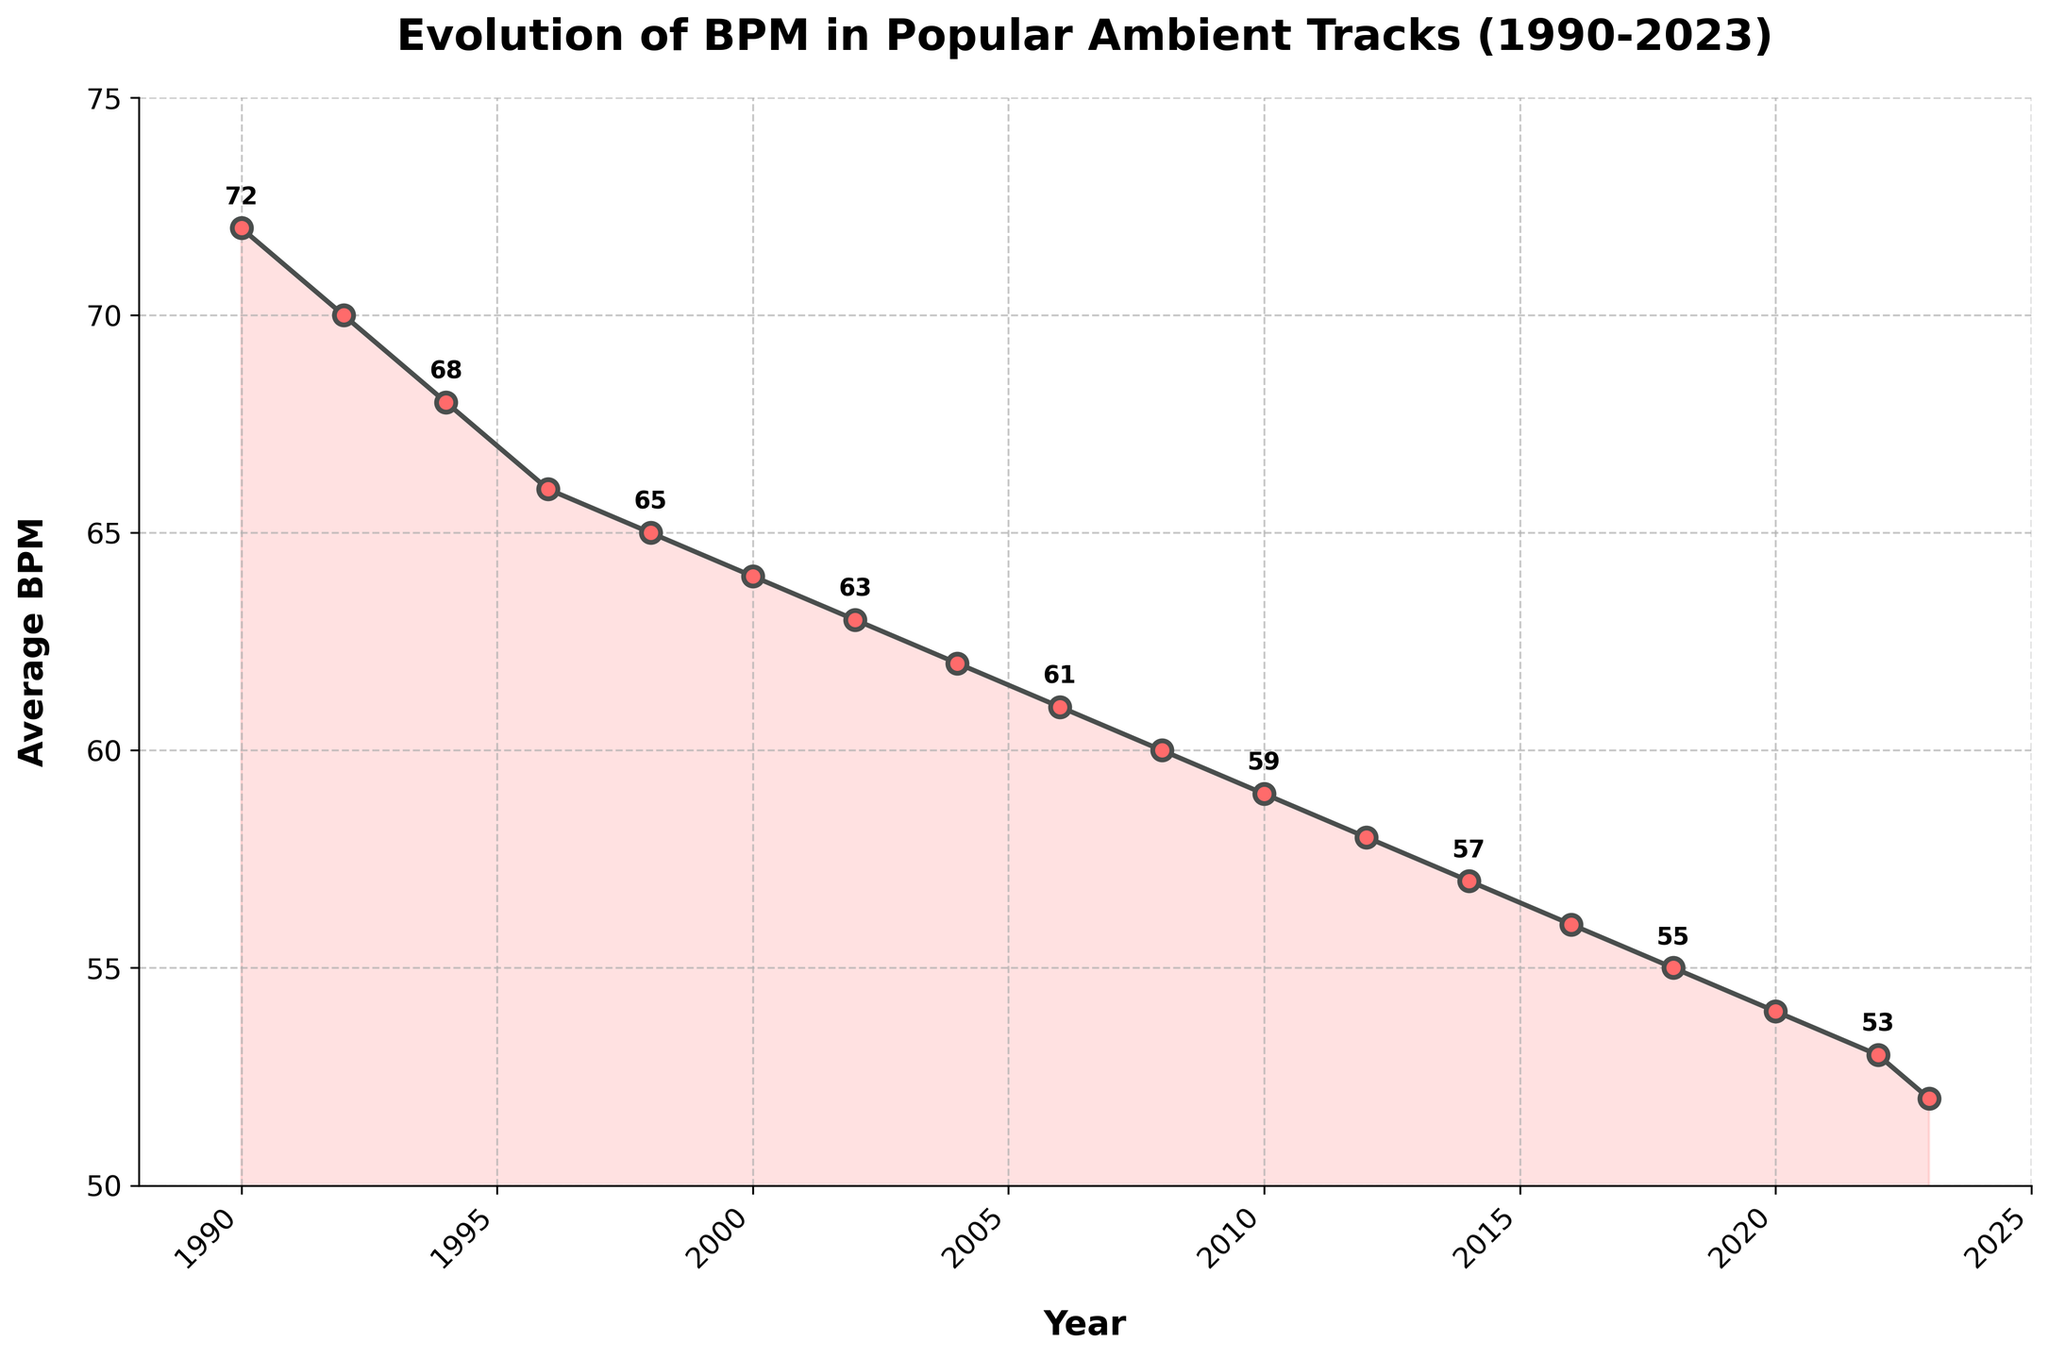What is the average BPM in 2018? The average BPM in 2018 can be directly read from the figure, which has clear labeled markers for each year. In 2018, the marker indicates an average BPM value of 55.
Answer: 55 Between which years did the average BPM drop by 2 beats per minute for the first time? We need to find a period where the difference between the average BPMs of consecutive years is exactly 2. Reviewing the intervals, the first noticeable drop by 2 BPM occurs between 1990 and 1992 (from 72 to 70).
Answer: 1990 to 1992 What is the overall trend in average BPM from 1990 to 2023? Observing the plot overall, the line gradually slopes downward from 1990 to 2023, indicating a continuous decrease in BPM over time.
Answer: Decreasing How much did the average BPM decrease from 1990 to 2023? Subtract the BPM value in 2023 from the BPM value in 1990. The BPM in 2023 is 52 and in 1990 is 72. Thus, 72 - 52 = 20.
Answer: 20 In which two consecutive years was the smallest drop in BPM recorded? To find this, we examine the changes between each pair of consecutive years. The smallest drop would be from 2000 to 2002, where it only drops from 64 to 63 BPM, which is a drop of 1 BPM.
Answer: 2000 to 2002 How many years does it take for the BPM to drop below 60? First, locate the point where the BPM reaches 60, which happens in 2008. The initial year is 1990. Hence, 2008 - 1990 = 18 years.
Answer: 18 Which year had the highest average BPM? By inspecting all data points, the BPM is highest at 72 in the year 1990.
Answer: 1990 What's the rate of BPM decrease per decade on average from 1990 to 2020? Find the change in BPM over each decade and then average these changes. From 1990 to 2000, it decreases from 72 to 64, a change of 8 BPM. From 2000 to 2010, it falls from 64 to 59, a change of 5 BPM. From 2010 to 2020, it decreases from 59 to 54, a change of 5 BPM. Thus, the average is (8 + 5 + 5) / 3 ≈ 6 BPM per decade.
Answer: 6 BPM per decade 